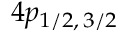<formula> <loc_0><loc_0><loc_500><loc_500>4 p _ { 1 / 2 , \, 3 / 2 }</formula> 